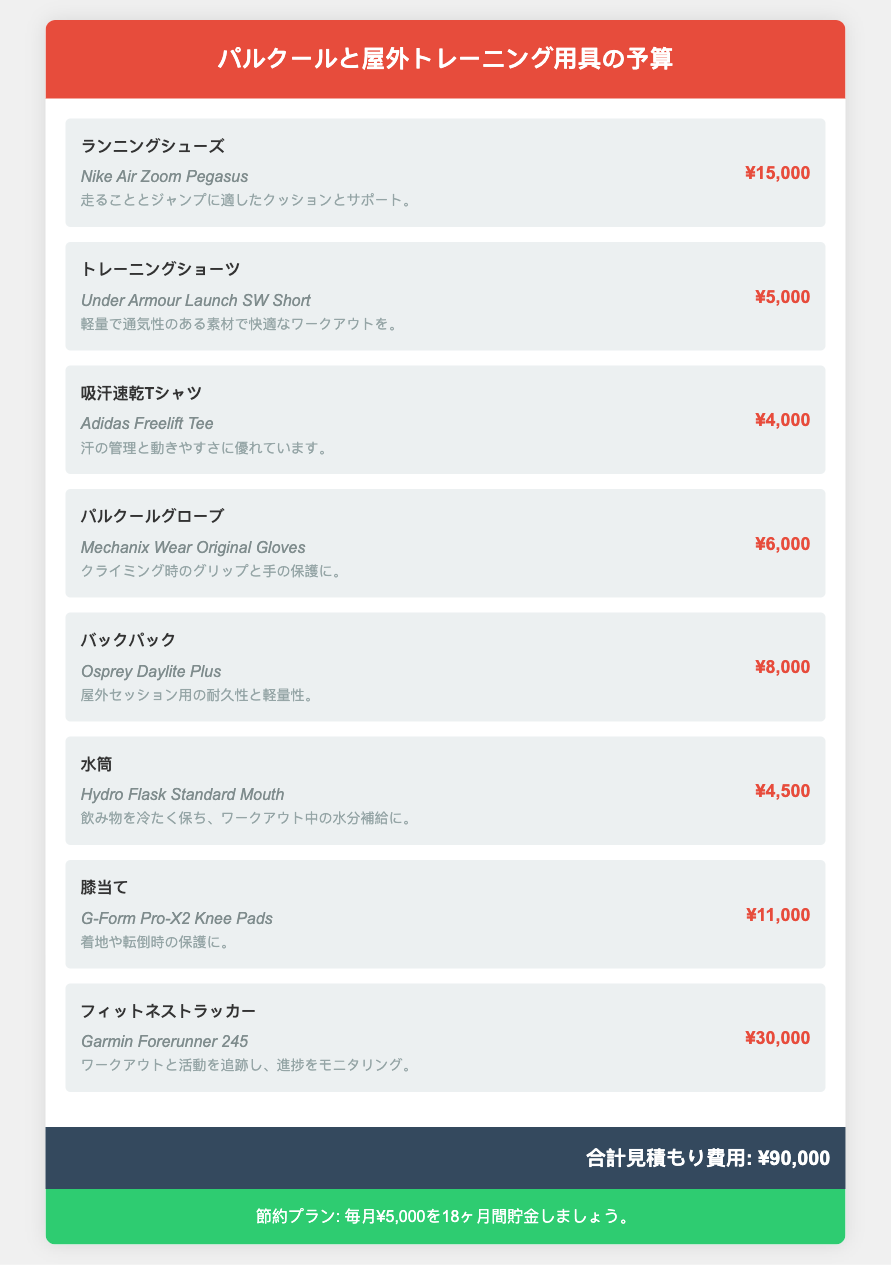What is the total estimated cost? The total estimated cost is indicated at the bottom of the document, summing up the individual item costs.
Answer: ¥90,000 How much do the running shoes cost? The cost of the running shoes is listed alongside the item details in the document.
Answer: ¥15,000 What is the brand of the knee pads? The brand of the knee pads is included in the item details for that specific gear.
Answer: G-Form Which item costs the most? The highest cost item is identified by comparing the prices of all items listed in the budget.
Answer: ¥30,000 How many months is the savings plan for? The savings plan duration is specified as part of the savings information provided at the end of the document.
Answer: 18ヶ月 What type of shirt is listed? The specific type of shirt is described under its item details, reflecting the kind of apparel included in the outdoor workout gear.
Answer: 吸汗速乾Tシャツ What is the brand of the backpack? The brand name of the backpack is located next to the item in the budget details.
Answer: Osprey What does the training shorts provide? The benefit of the training shorts is mentioned in their notes, summarizing their practical use.
Answer: 快適なワークアウト Which fitness tracker is mentioned? The name of the fitness tracker is provided within the item list in the document.
Answer: Garmin Forerunner 245 